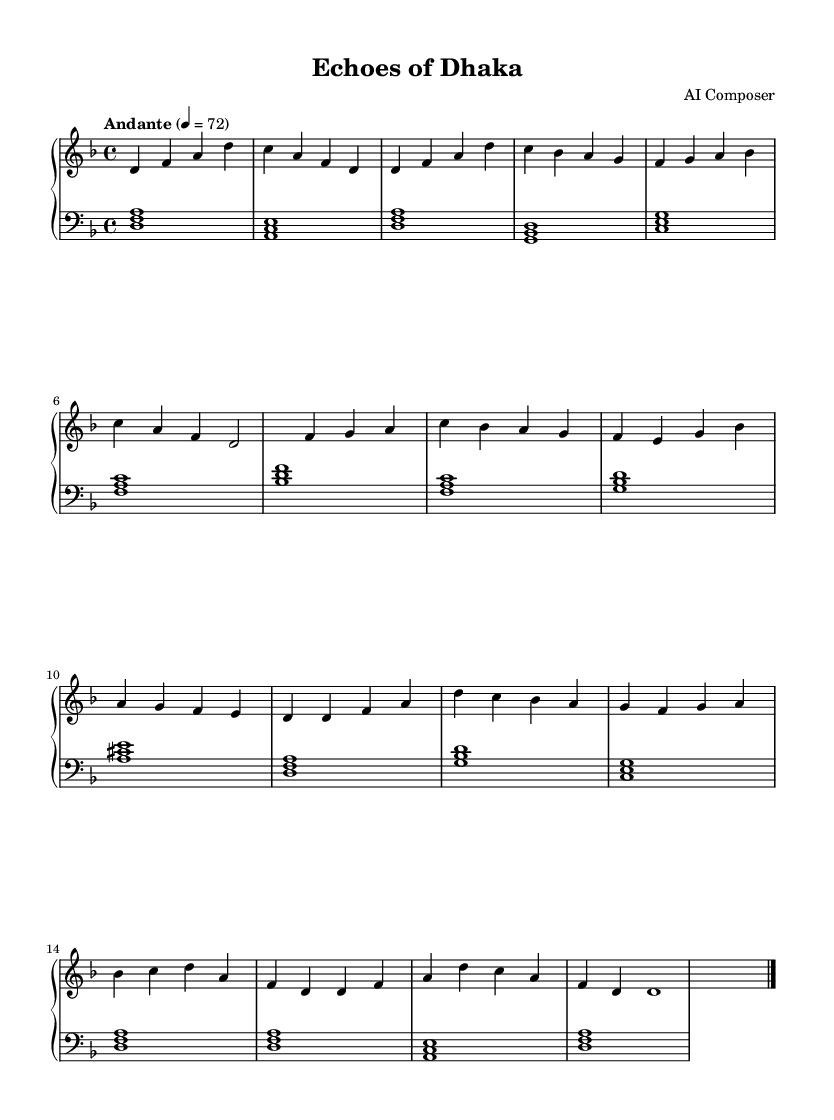What is the key signature of this music? The key signature is D minor, indicated by one flat (B♭).
Answer: D minor What is the time signature of the piece? The time signature is 4/4, meaning there are four beats per measure.
Answer: 4/4 What is the tempo marking for this piece? The tempo is marked as Andante, which typically translates to a moderate pace.
Answer: Andante How many sections are there in the piece? There are three main sections: A, B, and A prime (A').
Answer: Three What is the first note of the right hand in the intro? The first note in the right hand during the intro is D.
Answer: D In the B section, what is the last note played in the left hand? In the B section, the last note in the left hand is A.
Answer: A What is the overall structure of the piece based on section labeling? The overall structure is Intro, A, B, A prime, and Coda, which creates a narrative flow.
Answer: Intro, A, B, A', Coda 